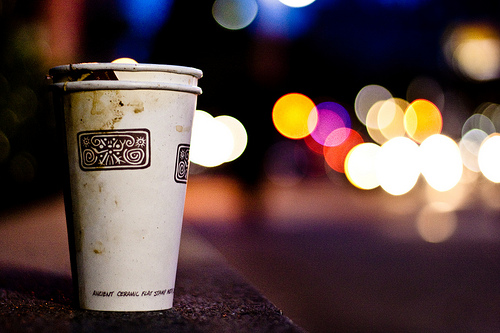<image>
Is the cup next to the cup? No. The cup is not positioned next to the cup. They are located in different areas of the scene. 